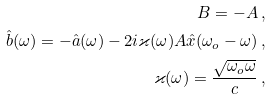<formula> <loc_0><loc_0><loc_500><loc_500>B = - A \, , \\ \hat { b } ( \omega ) = - \hat { a } ( \omega ) - 2 i \varkappa ( \omega ) A \hat { x } ( \omega _ { o } - \omega ) \, , \\ \varkappa ( \omega ) = \frac { \sqrt { \omega _ { o } \omega } } { c } \, ,</formula> 